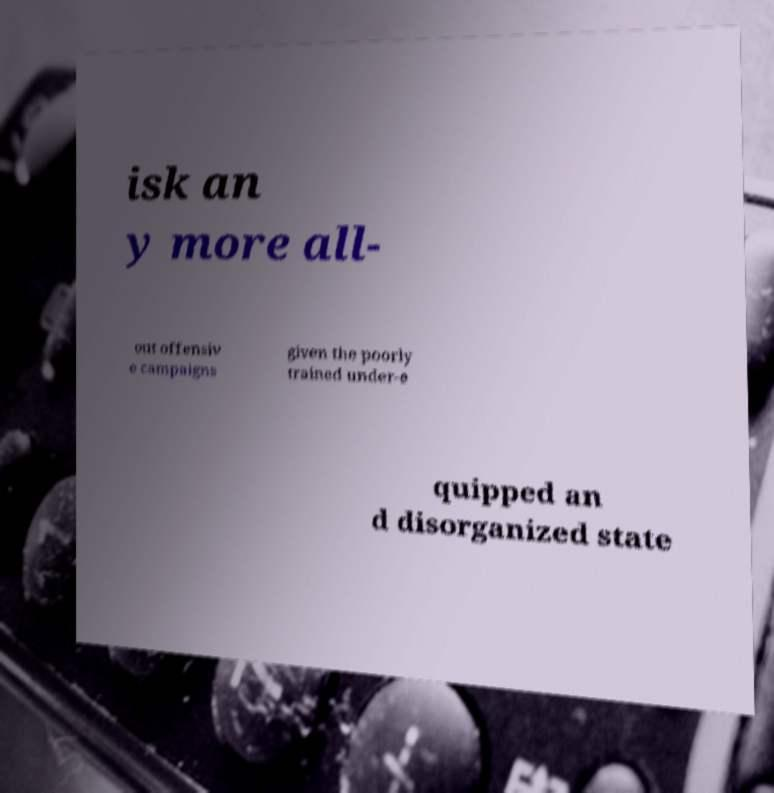Can you accurately transcribe the text from the provided image for me? isk an y more all- out offensiv e campaigns given the poorly trained under-e quipped an d disorganized state 